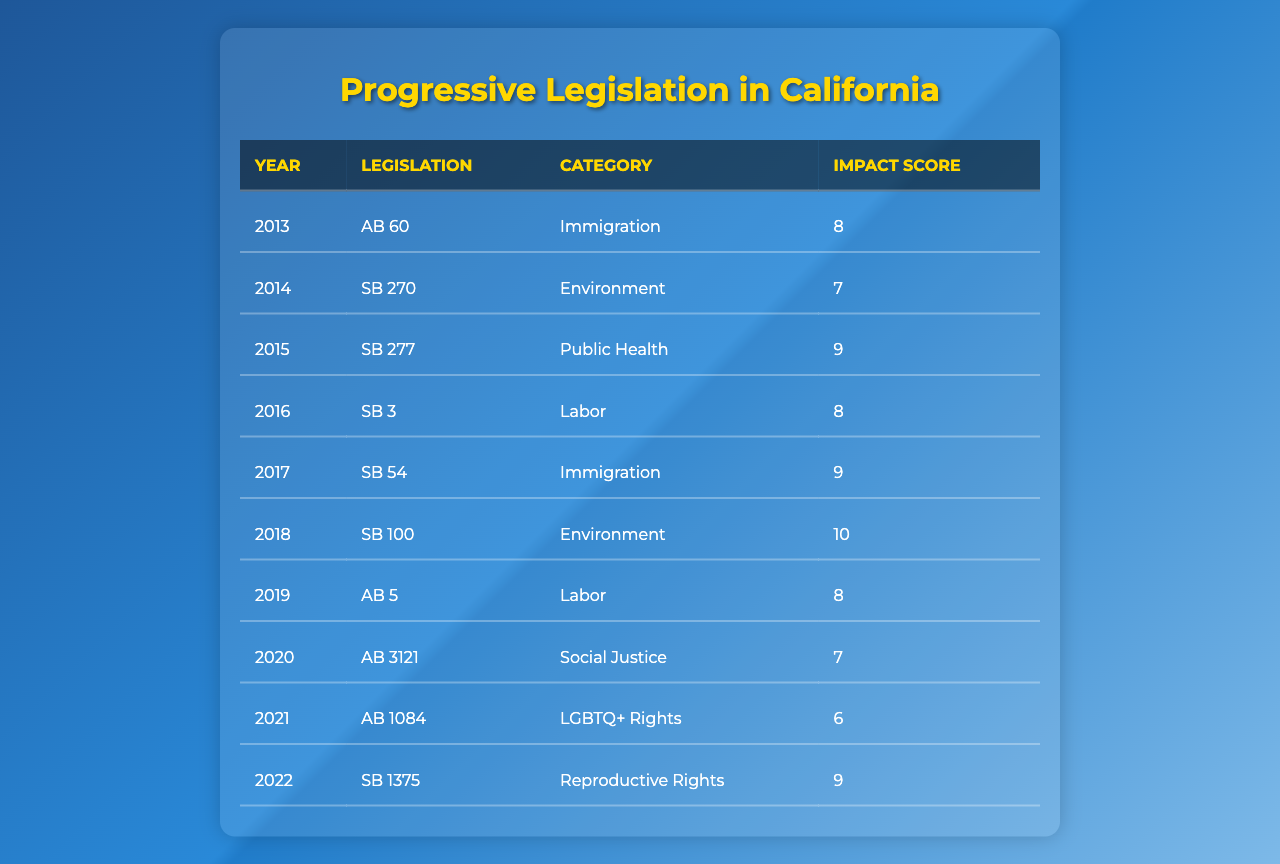What progressive legislation was passed in California in 2020? Referring to the table, the legislation passed in California in 2020 is "AB 3121."
Answer: AB 3121 What was the highest impact score of a piece of legislation in 2018? In 2018, the table shows that "SB 100" had an impact score of 10, which is the highest among that year’s legislation.
Answer: 10 Which category had the most legislation passed in the decade? The table shows that both the "Labor" and "Immigration" categories each have two pieces of legislation listed over the decade, making them the categories with the most legislation passed.
Answer: Labor and Immigration What is the average impact score of all the legislation passed in California over the last decade? To find the average, we first sum all the impact scores: (8 + 7 + 9 + 8 + 9 + 10 + 8 + 7 + 6 + 9) = 81. There are 10 pieces of legislation, so the average is 81/10 = 8.1.
Answer: 8.1 Was any legislation passed in the years 2014 and 2021 categorized under "Social Justice"? Referring to the table, the legislation from 2014 is "SB 270" categorized under "Environment" and in 2021 it is "AB 1084" categorized under "LGBTQ+ Rights." Therefore, none were categorized under "Social Justice."
Answer: No What year had the lowest impact score for its legislation? The table shows that 2021, with "AB 1084" scoring 6, has the lowest impact score compared to other years listed.
Answer: 2021 Which legislation, passed in 2019, has an impact score of 8? The table indicates "AB 5," passed in 2019, has an impact score of 8.
Answer: AB 5 What is the difference in impact scores between the highest and lowest scored legislation? The highest score is 10 (from SB 100 in 2018), and the lowest is 6 (from AB 1084 in 2021). The difference is 10 - 6 = 4.
Answer: 4 Did California pass any immigration-related legislation with an impact score of 9 or higher between 2013 and 2017? The legislation "AB 60" in 2013 has an impact score of 8, while "SB 54" in 2017 has an impact score of 9. Thus, California did pass immigration-related legislation with an impact score of 9.
Answer: Yes How many years had legislation with an impact score of 9 or higher? The years with legislation that scored 9 or above are 2015 (SB 277), 2017 (SB 54), 2018 (SB 100), and 2022 (SB 1375) which totals to 4 years.
Answer: 4 